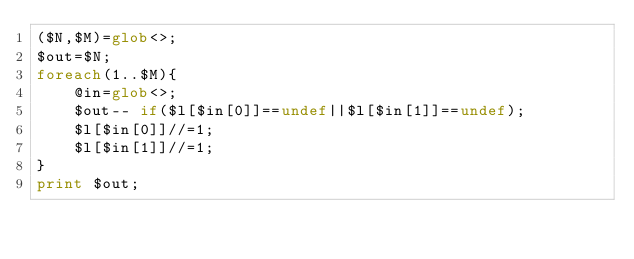Convert code to text. <code><loc_0><loc_0><loc_500><loc_500><_Perl_>($N,$M)=glob<>;
$out=$N;
foreach(1..$M){
    @in=glob<>;
    $out-- if($l[$in[0]]==undef||$l[$in[1]]==undef);
    $l[$in[0]]//=1;
    $l[$in[1]]//=1;
}
print $out;</code> 